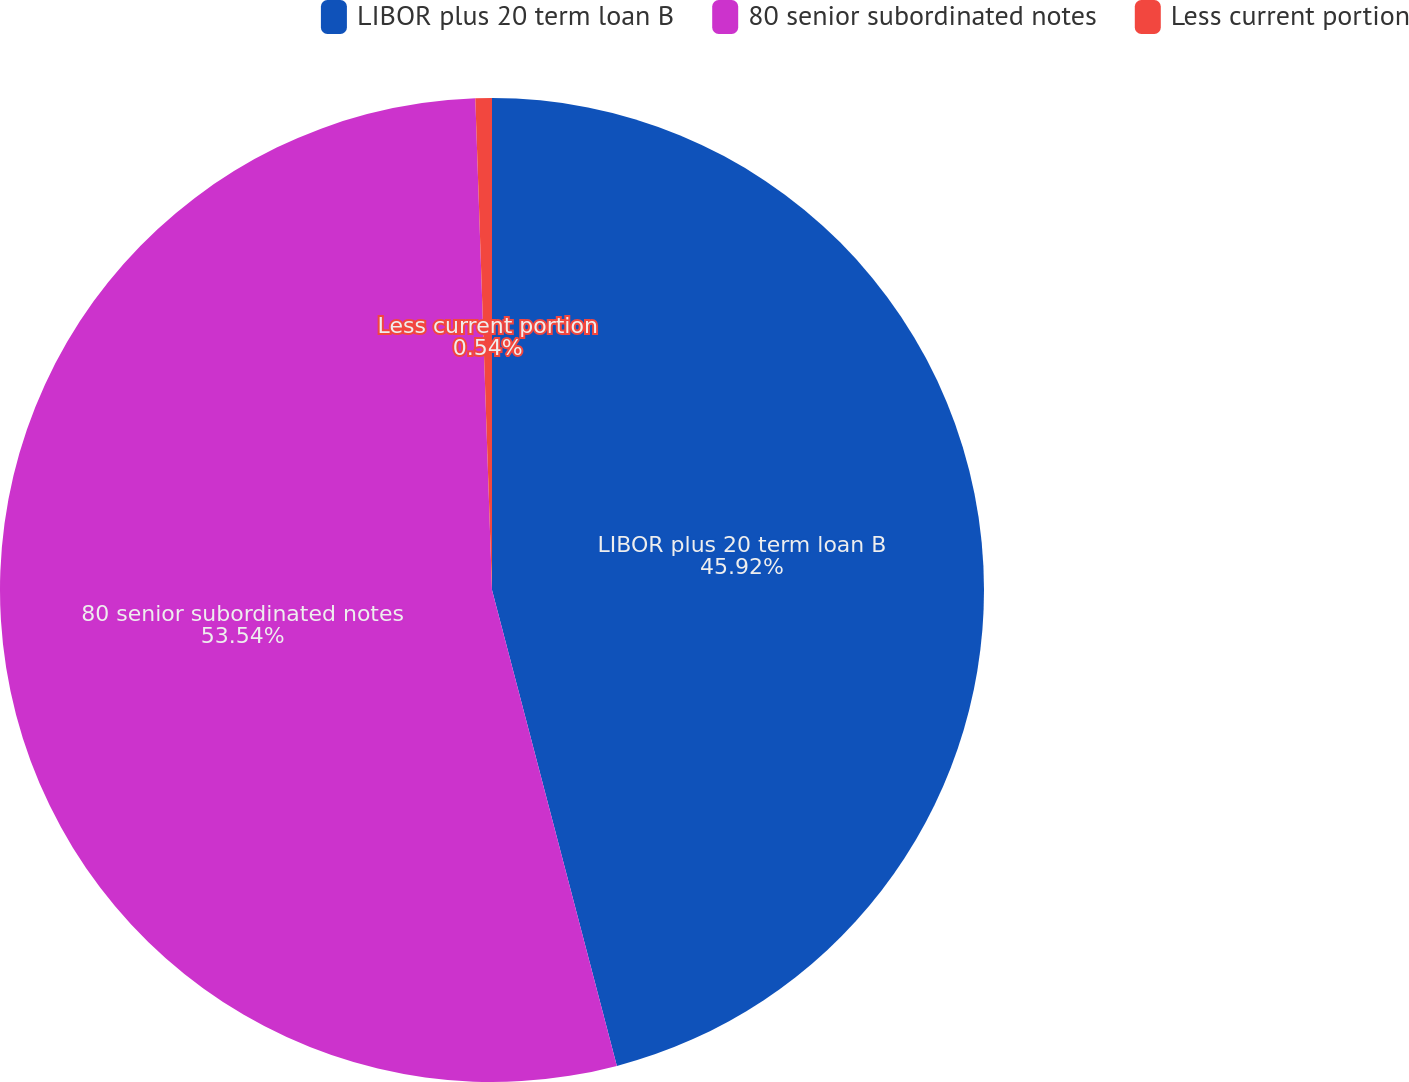<chart> <loc_0><loc_0><loc_500><loc_500><pie_chart><fcel>LIBOR plus 20 term loan B<fcel>80 senior subordinated notes<fcel>Less current portion<nl><fcel>45.92%<fcel>53.55%<fcel>0.54%<nl></chart> 